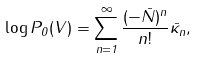<formula> <loc_0><loc_0><loc_500><loc_500>\log P _ { 0 } ( V ) = \sum _ { n = 1 } ^ { \infty } \frac { ( - \bar { N } ) ^ { n } } { n ! } \bar { \kappa } _ { n } ,</formula> 